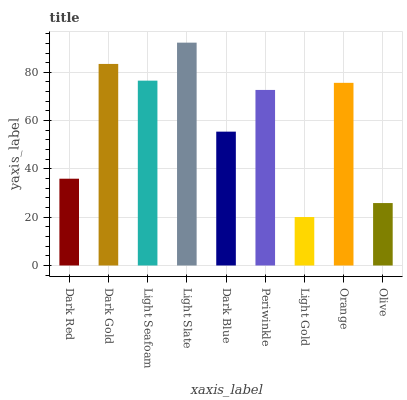Is Light Gold the minimum?
Answer yes or no. Yes. Is Light Slate the maximum?
Answer yes or no. Yes. Is Dark Gold the minimum?
Answer yes or no. No. Is Dark Gold the maximum?
Answer yes or no. No. Is Dark Gold greater than Dark Red?
Answer yes or no. Yes. Is Dark Red less than Dark Gold?
Answer yes or no. Yes. Is Dark Red greater than Dark Gold?
Answer yes or no. No. Is Dark Gold less than Dark Red?
Answer yes or no. No. Is Periwinkle the high median?
Answer yes or no. Yes. Is Periwinkle the low median?
Answer yes or no. Yes. Is Light Seafoam the high median?
Answer yes or no. No. Is Dark Blue the low median?
Answer yes or no. No. 